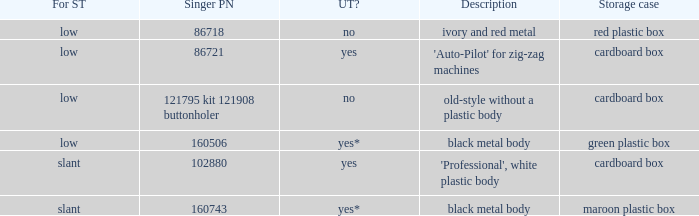What's the shank type of the buttonholer with red plastic box as storage case? Low. 